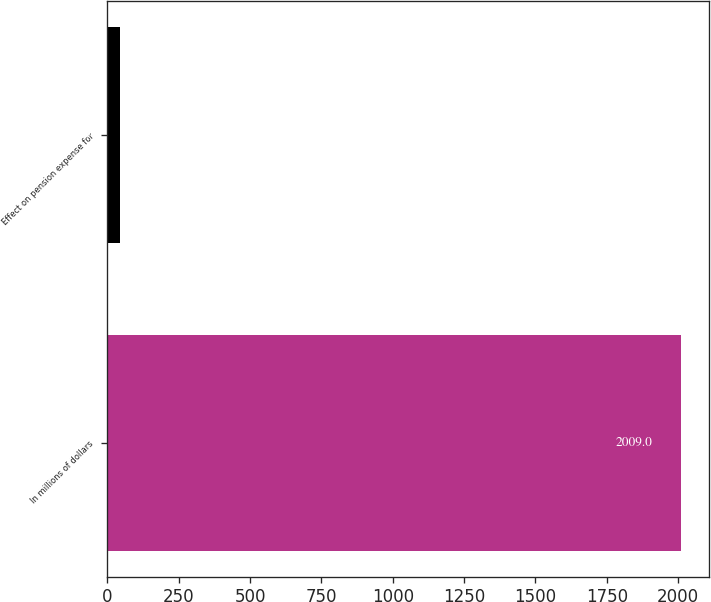<chart> <loc_0><loc_0><loc_500><loc_500><bar_chart><fcel>In millions of dollars<fcel>Effect on pension expense for<nl><fcel>2009<fcel>44<nl></chart> 